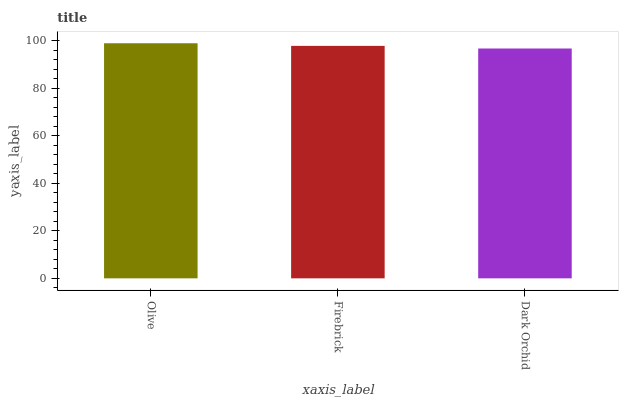Is Firebrick the minimum?
Answer yes or no. No. Is Firebrick the maximum?
Answer yes or no. No. Is Olive greater than Firebrick?
Answer yes or no. Yes. Is Firebrick less than Olive?
Answer yes or no. Yes. Is Firebrick greater than Olive?
Answer yes or no. No. Is Olive less than Firebrick?
Answer yes or no. No. Is Firebrick the high median?
Answer yes or no. Yes. Is Firebrick the low median?
Answer yes or no. Yes. Is Olive the high median?
Answer yes or no. No. Is Dark Orchid the low median?
Answer yes or no. No. 